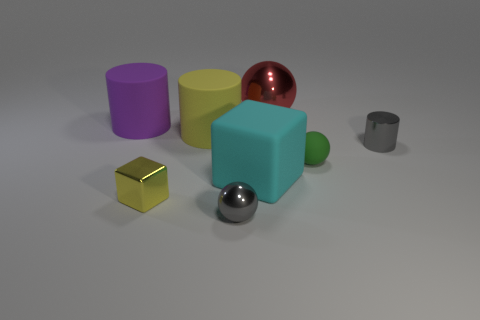Do the rubber thing that is on the right side of the large cyan rubber object and the thing that is behind the big purple rubber object have the same size?
Your response must be concise. No. What shape is the tiny gray object right of the tiny gray thing in front of the large cube?
Offer a very short reply. Cylinder. What number of red metallic cubes have the same size as the gray metallic ball?
Offer a terse response. 0. Are there any green cylinders?
Ensure brevity in your answer.  No. Is there any other thing that is the same color as the small block?
Keep it short and to the point. Yes. The purple object that is the same material as the large cyan object is what shape?
Offer a very short reply. Cylinder. What color is the ball that is behind the gray object that is on the right side of the metal ball to the left of the big red ball?
Provide a succinct answer. Red. Is the number of small gray metallic cylinders in front of the gray metallic cylinder the same as the number of tiny balls?
Provide a short and direct response. No. Is there anything else that is the same material as the tiny gray cylinder?
Give a very brief answer. Yes. There is a big rubber cube; does it have the same color as the large rubber object behind the big yellow cylinder?
Your response must be concise. No. 